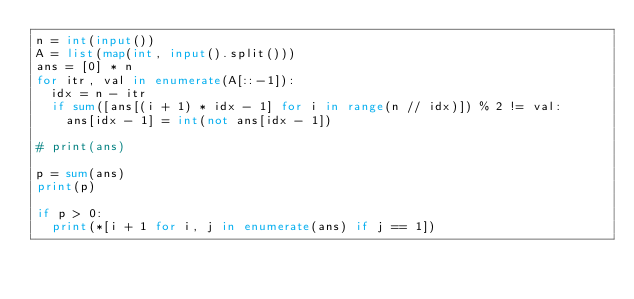<code> <loc_0><loc_0><loc_500><loc_500><_Python_>n = int(input())
A = list(map(int, input().split()))
ans = [0] * n
for itr, val in enumerate(A[::-1]):
  idx = n - itr
  if sum([ans[(i + 1) * idx - 1] for i in range(n // idx)]) % 2 != val:
    ans[idx - 1] = int(not ans[idx - 1])

# print(ans)
    
p = sum(ans)
print(p)    

if p > 0:
  print(*[i + 1 for i, j in enumerate(ans) if j == 1])
</code> 